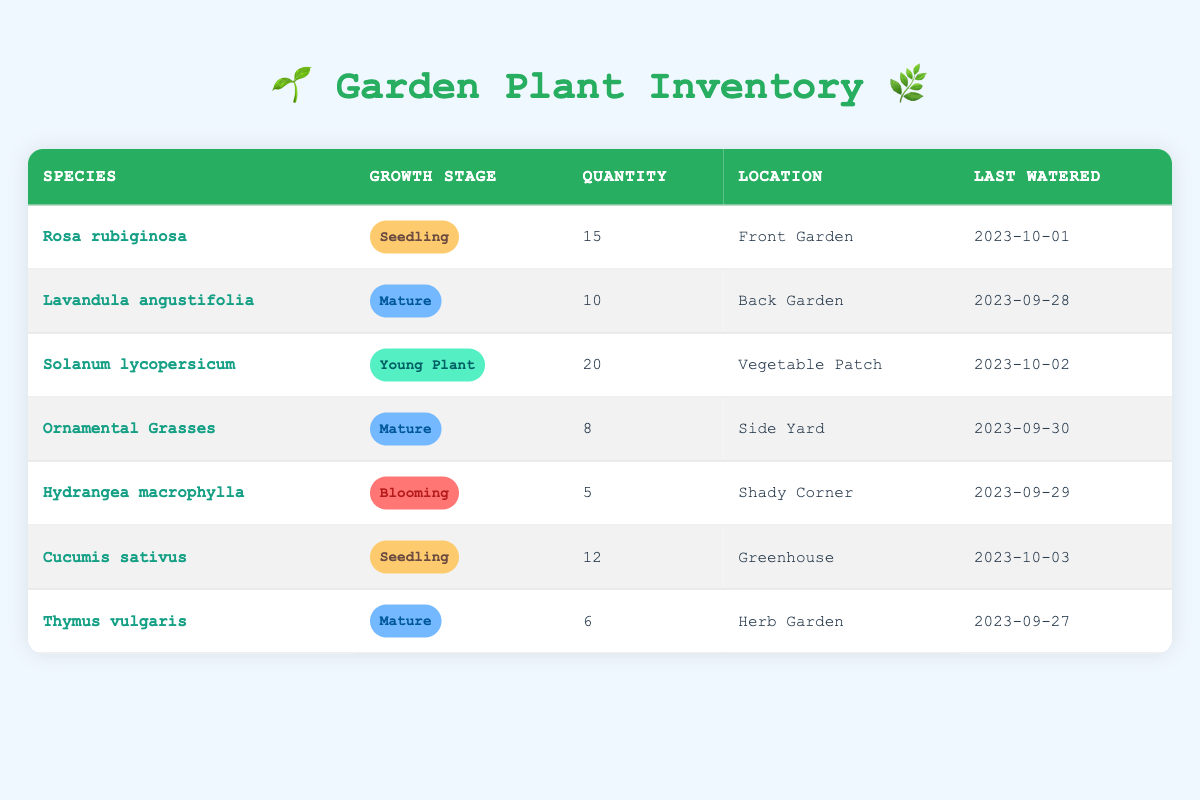What species is located in the Front Garden? Referring to the table, we can see that the species listed for the Front Garden is "Rosa rubiginosa".
Answer: Rosa rubiginosa How many "Mature" plants are there in total? From the table, the following species are classified as "Mature": Lavandula angustifolia (10), Ornamental Grasses (8), and Thymus vulgaris (6). Adding these gives us: 10 + 8 + 6 = 24.
Answer: 24 Is "Hydrangea macrophylla" currently blooming? According to the table, "Hydrangea macrophylla" is in the "Blooming" growth stage, which confirms that it is currently blooming.
Answer: Yes Which plant species was last watered on 2023-10-03? Looking at the last watered dates, we find that "Cucumis sativus" has the last watered date of 2023-10-03.
Answer: Cucumis sativus What is the total quantity of seedlings in the inventory? The seedlings listed in the table are: Rosa rubiginosa (15) and Cucumis sativus (12). To find the total quantity of seedlings, we add these numbers: 15 + 12 = 27.
Answer: 27 Which location has the least quantity of plants? By reviewing the quantity in each location, we see that the "Shady Corner" has 5 (Hydrangea macrophylla), which is the least compared to others.
Answer: Shady Corner Are there any plants in the "Young Plant" stage? The table shows that "Solanum lycopersicum" is the only plant listed as a "Young Plant". Therefore, there is one.
Answer: Yes How many plants are located in the Vegetable Patch? According to the table, there is one species located in the Vegetable Patch, which is "Solanum lycopersicum," with a quantity of 20.
Answer: 20 What is the average quantity of "Mature" plants across all locations? The table shows there are three "Mature" plants with quantities of: Lavandula angustifolia (10), Ornamental Grasses (8), and Thymus vulgaris (6). The average is calculated as: (10 + 8 + 6) / 3 = 24 / 3 = 8.
Answer: 8 